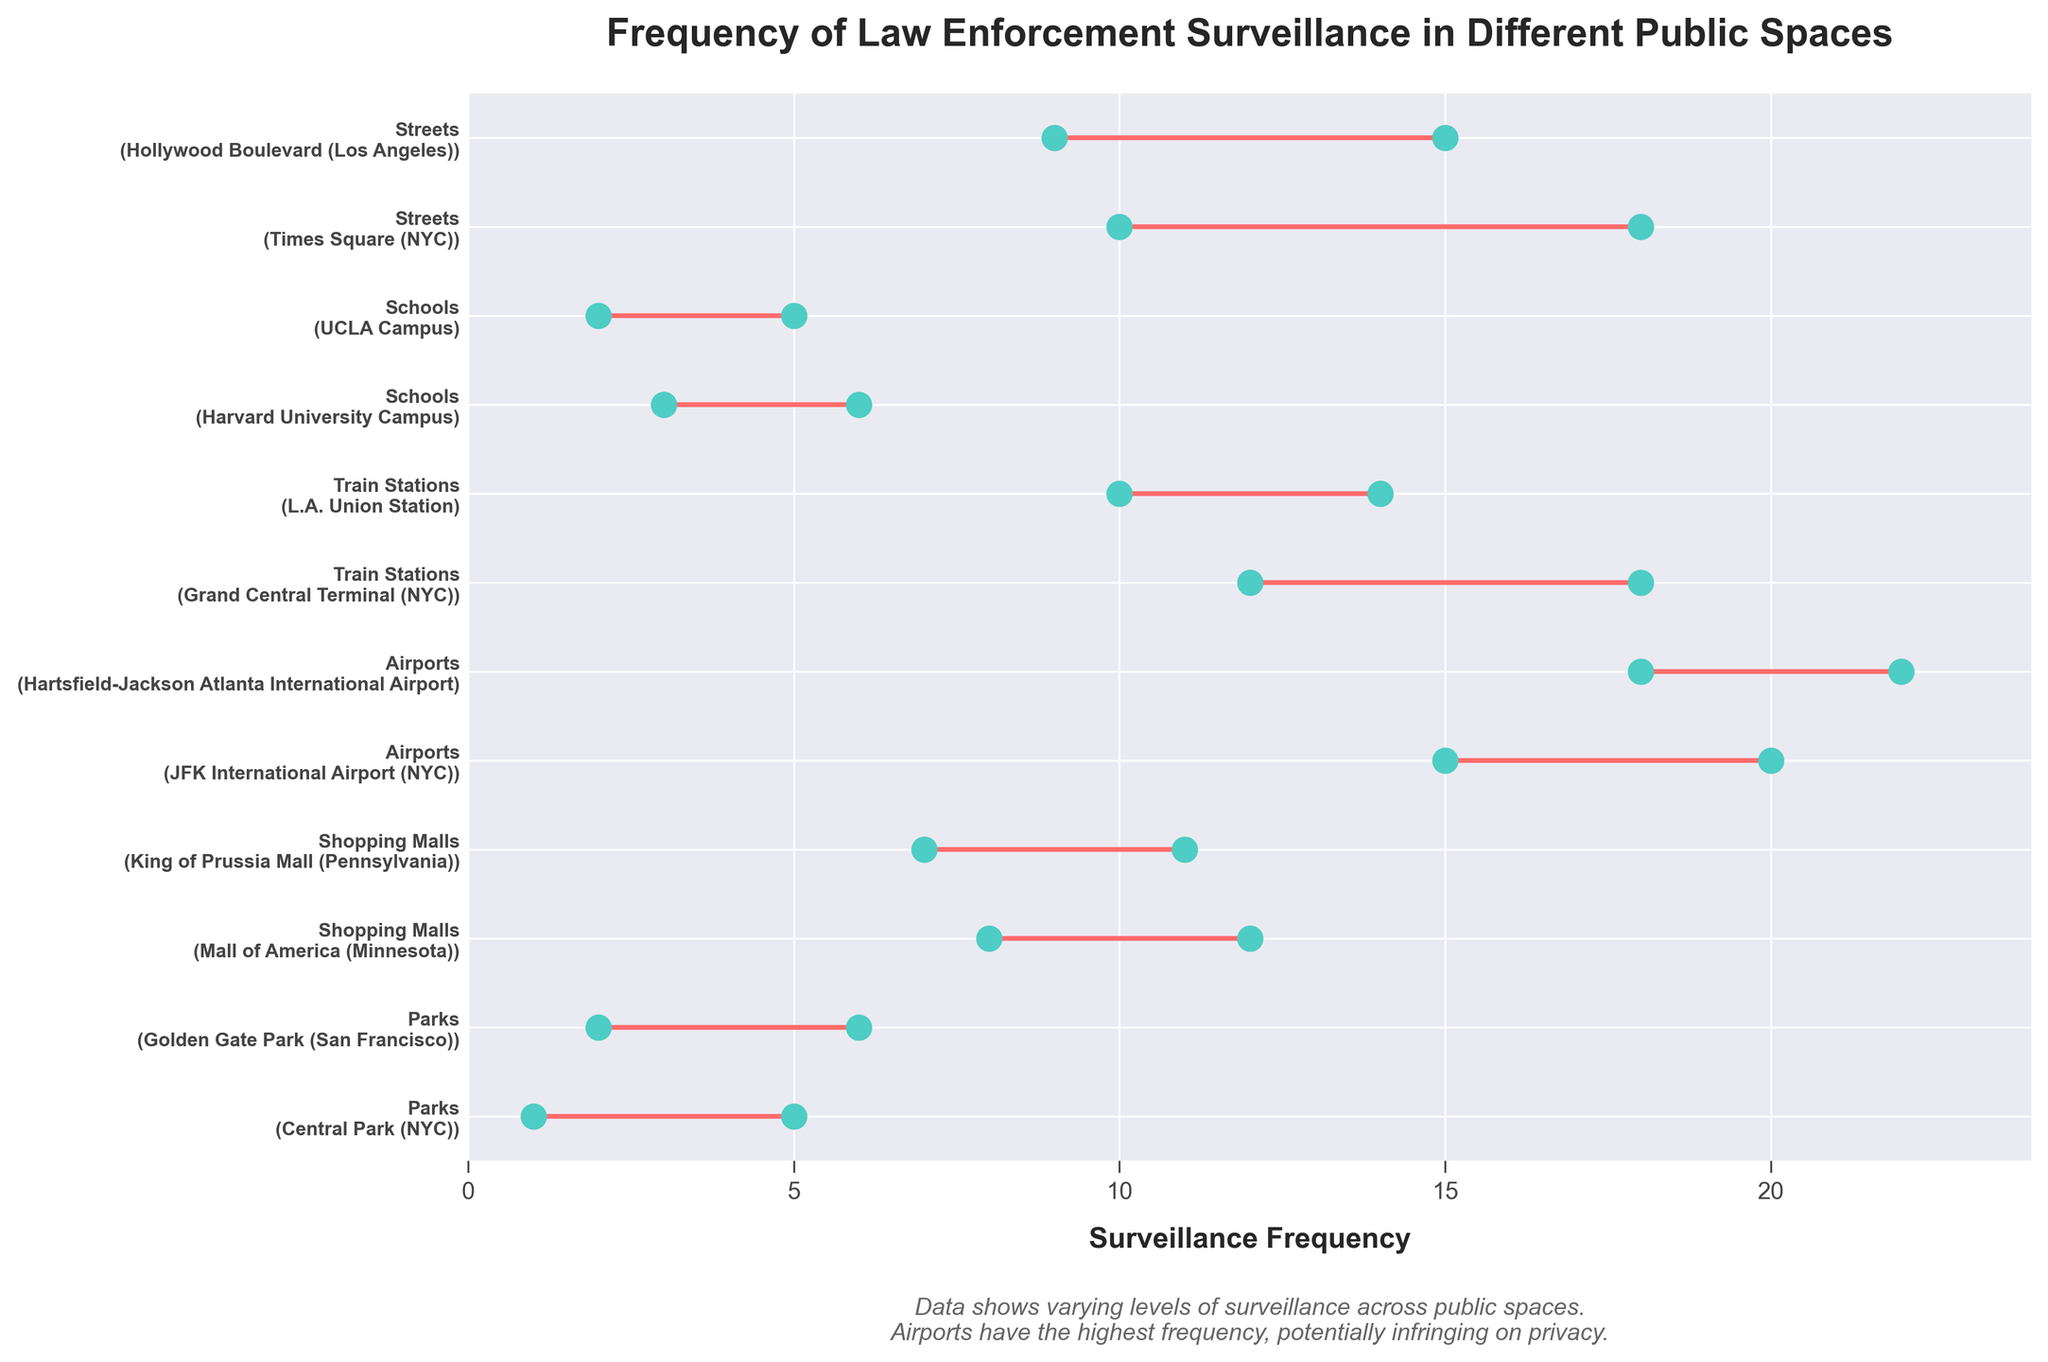What is the title of the figure? Look at the top of the figure where the large text is located; that's usually where the title is placed.
Answer: Frequency of Law Enforcement Surveillance in Different Public Spaces What is the y-axis labeled? Check the left side of the figure for vertical text or labels representing locations or categories.
Answer: Public Spaces and Locations What is the maximum surveillance frequency at JFK International Airport? Identify the dot plot corresponding to JFK International Airport under the 'Airports' category, then find the rightmost value.
Answer: 20 What is the surveillance frequency range for Hollywood Boulevard? Locate the dot plot for Hollywood Boulevard under the 'Streets' category, then find both the leftmost and rightmost values.
Answer: 9 to 15 Which public space has the highest minimum surveillance frequency? Compare the minimum points for each public space; the one with the highest starting point is the answer.
Answer: Hartsfield-Jackson Atlanta International Airport Do shopping malls in general have higher surveillance frequencies compared to parks? Compare the ranges of the 'Shopping Malls' categories with those in the 'Parks' categories to determine which overall values are higher.
Answer: Yes, shopping malls generally have higher surveillance What is the overall range of surveillance frequency in train stations? Look at the minimum and maximum points for both 'Grand Central Terminal' and 'L.A. Union Station.' The lowest minimum and highest maximum give the range.
Answer: 10 to 18 How does the frequency range in streets compare to parks? Find the range of frequencies for 'Streets' and 'Parks,' then compare them to see which is higher and by how much.
Answer: Streets: 9 to 18, Parks: 1 to 6. Streets have a higher range What is the average maximum surveillance frequency among all public spaces? Add all the highest maximum frequencies across each public space and then divide by the number of public spaces (12). \(\frac{1+2+8+7+15+18+12+10+3+2+10+9+5+6+12+11+18+22+18+14+6+5+5+12+15+20+6+11+11+22}{12}\)
Answer: 11.5 Which location has the most significant variability in surveillance frequency? Evaluate the difference between the minimum and maximum frequencies for each location, and the one with the largest difference indicates the most variability.
Answer: Hartsfield-Jackson Atlanta International Airport (4) 